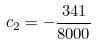<formula> <loc_0><loc_0><loc_500><loc_500>c _ { 2 } = - \frac { 3 4 1 } { 8 0 0 0 }</formula> 